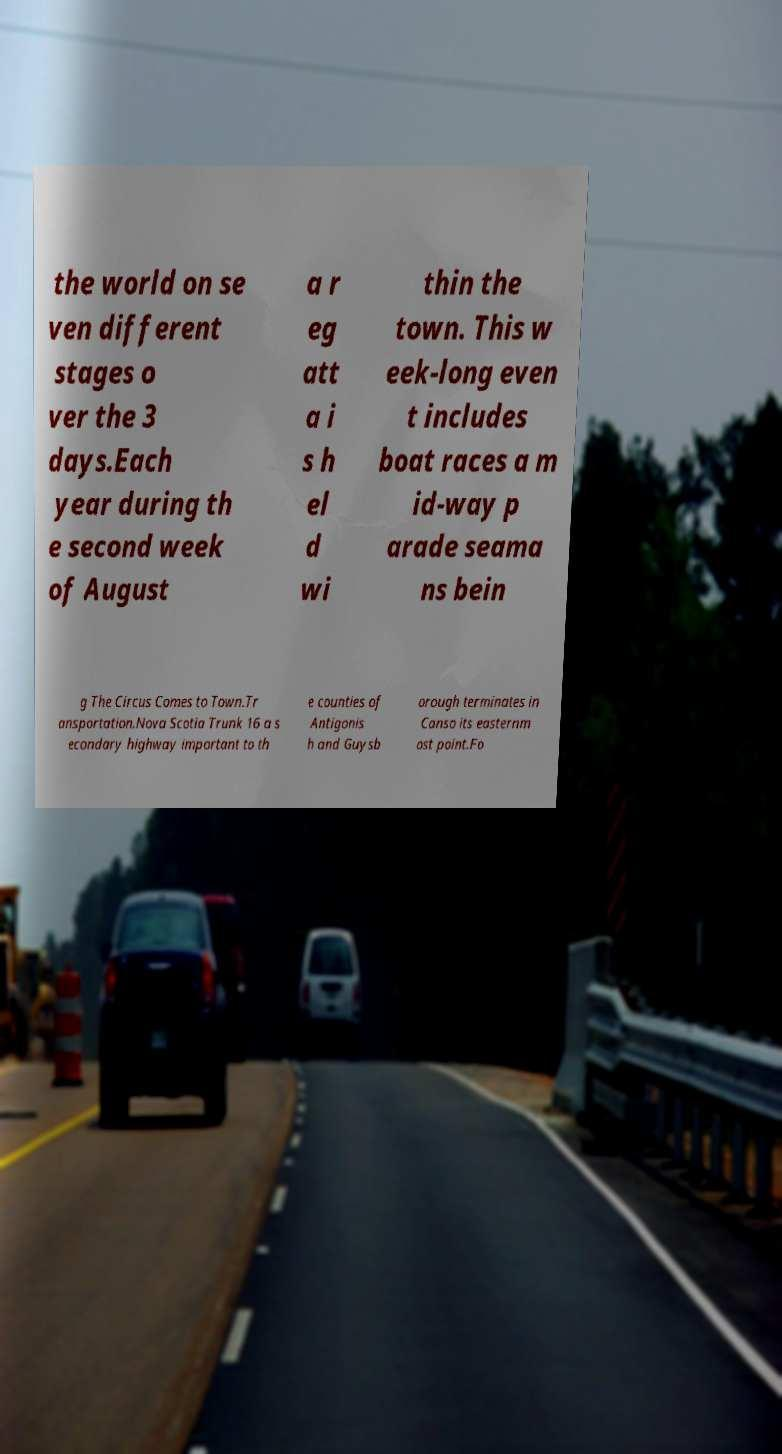There's text embedded in this image that I need extracted. Can you transcribe it verbatim? the world on se ven different stages o ver the 3 days.Each year during th e second week of August a r eg att a i s h el d wi thin the town. This w eek-long even t includes boat races a m id-way p arade seama ns bein g The Circus Comes to Town.Tr ansportation.Nova Scotia Trunk 16 a s econdary highway important to th e counties of Antigonis h and Guysb orough terminates in Canso its easternm ost point.Fo 